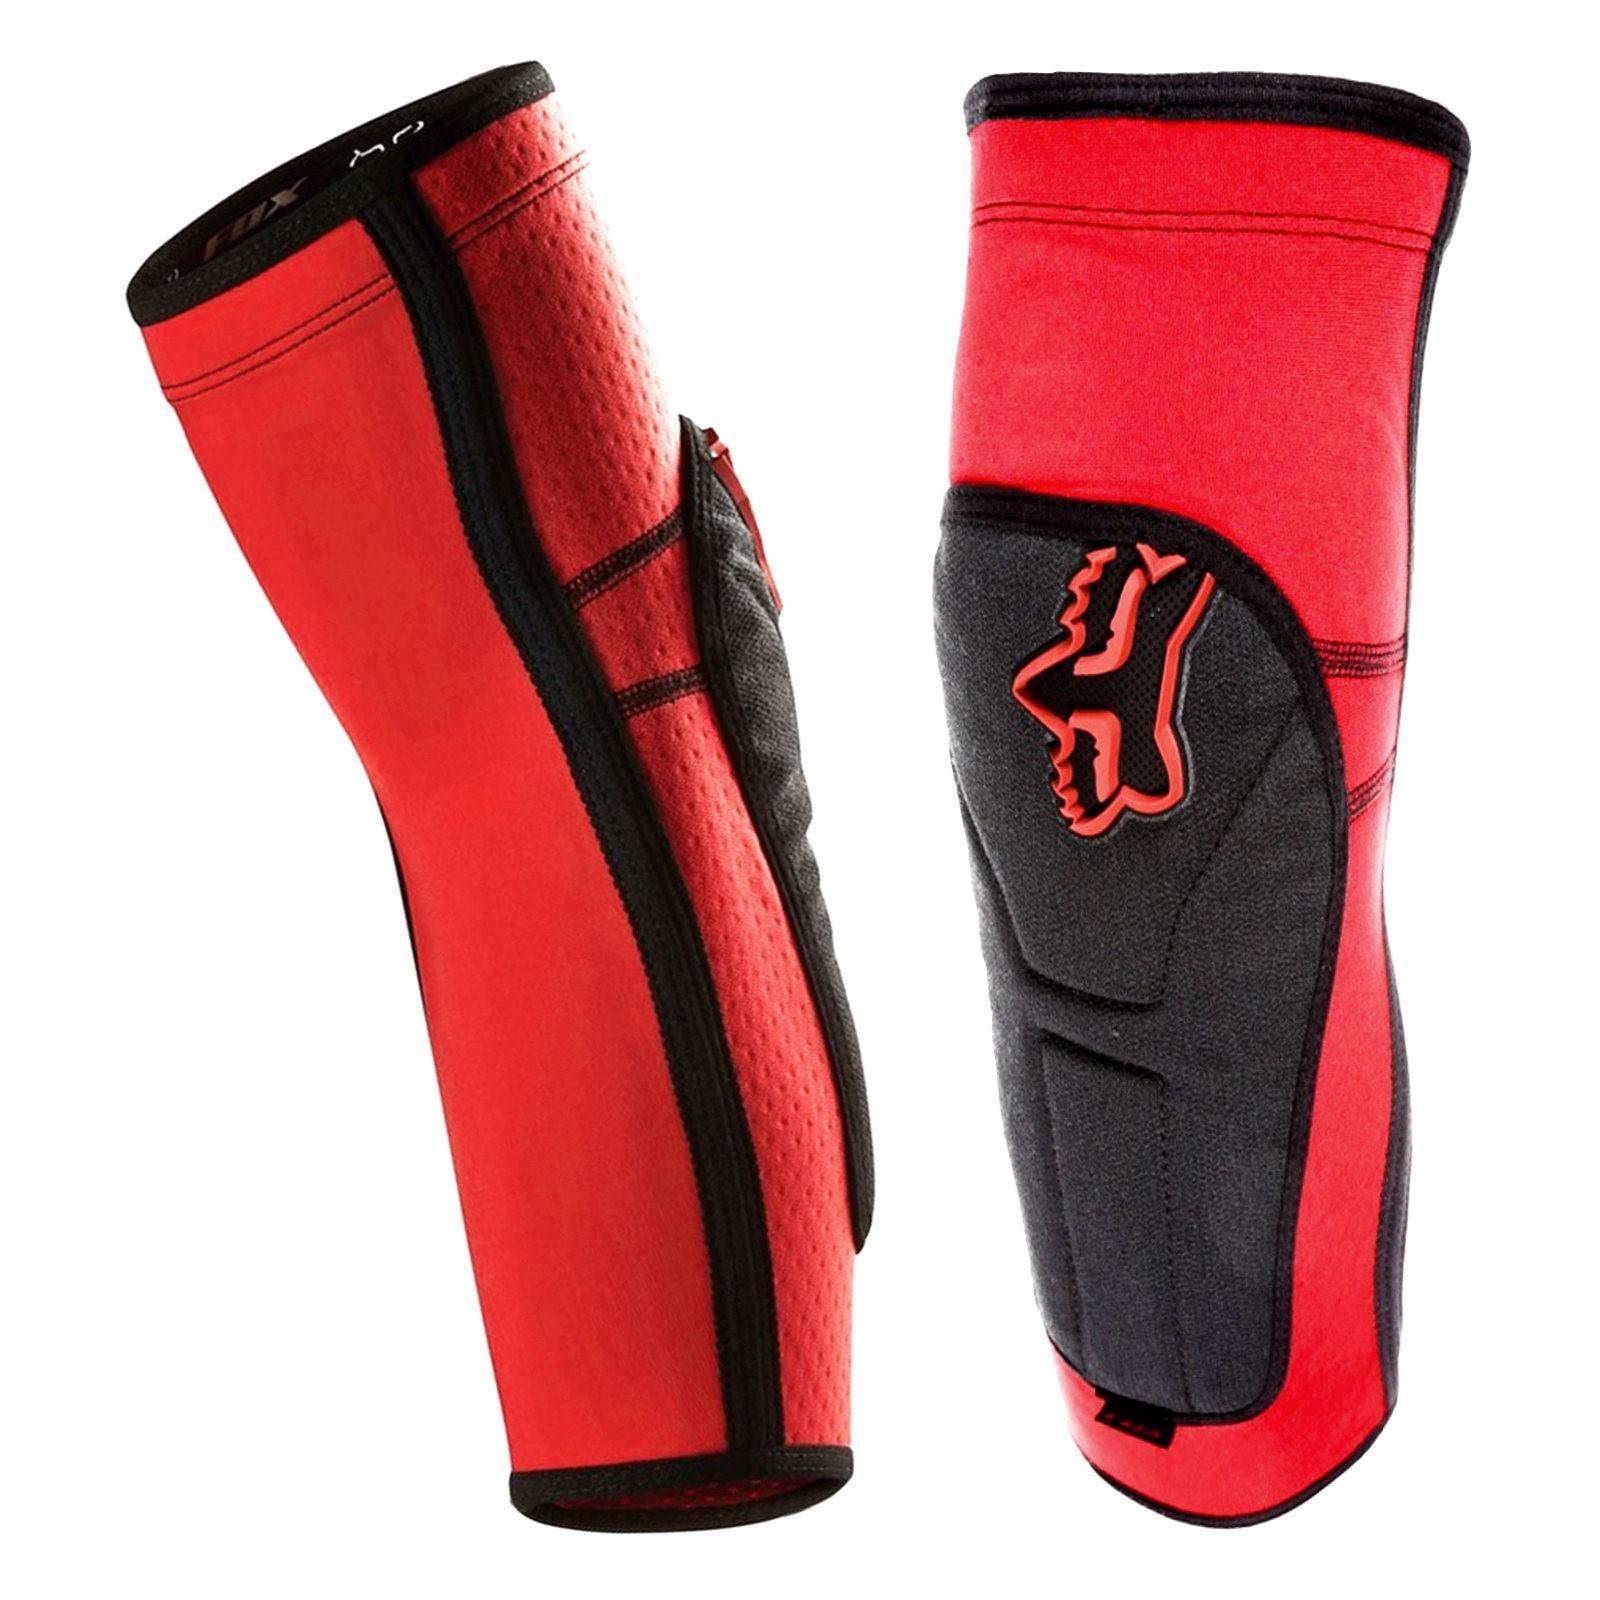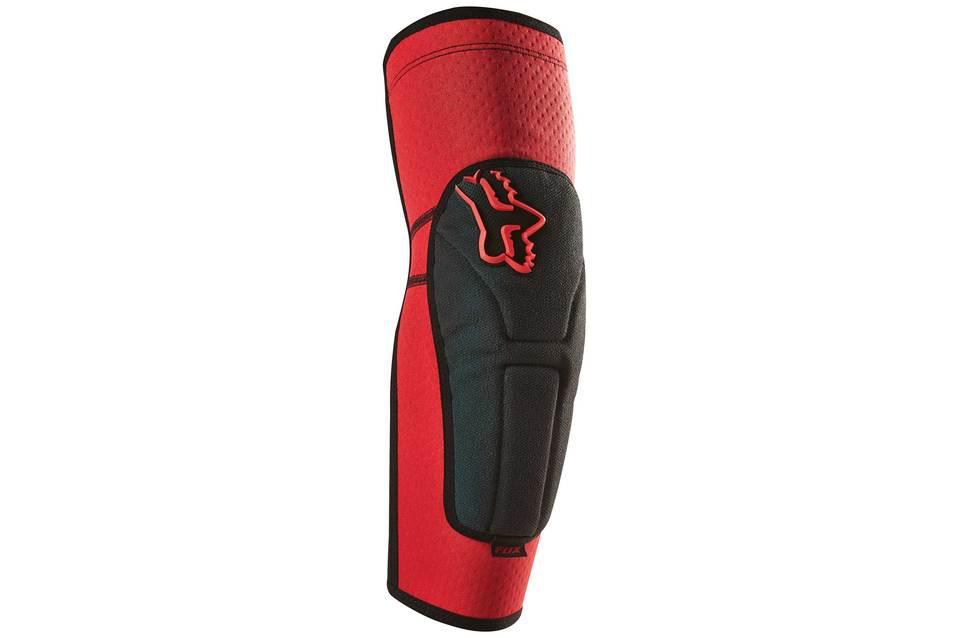The first image is the image on the left, the second image is the image on the right. For the images shown, is this caption "There are no less than two knee pads that are red and black in color" true? Answer yes or no. Yes. 